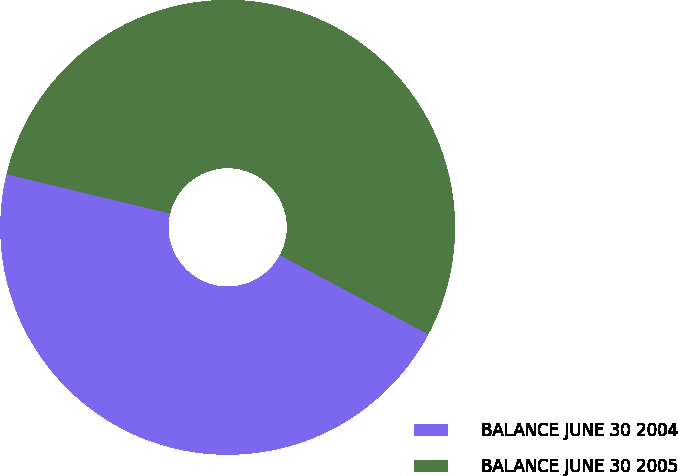Convert chart. <chart><loc_0><loc_0><loc_500><loc_500><pie_chart><fcel>BALANCE JUNE 30 2004<fcel>BALANCE JUNE 30 2005<nl><fcel>45.96%<fcel>54.04%<nl></chart> 